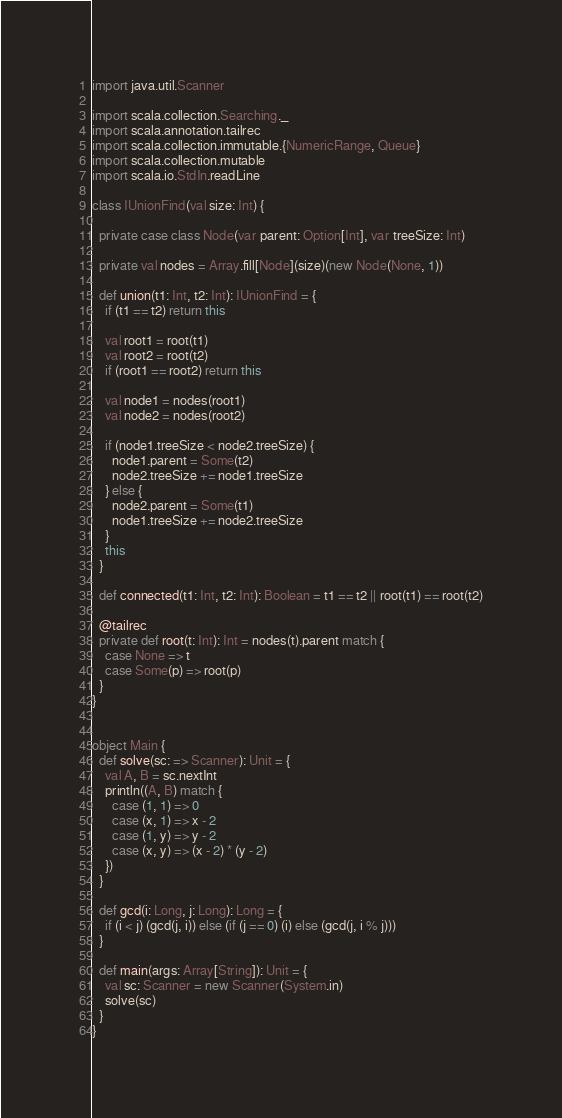Convert code to text. <code><loc_0><loc_0><loc_500><loc_500><_Scala_>import java.util.Scanner

import scala.collection.Searching._
import scala.annotation.tailrec
import scala.collection.immutable.{NumericRange, Queue}
import scala.collection.mutable
import scala.io.StdIn.readLine

class IUnionFind(val size: Int) {

  private case class Node(var parent: Option[Int], var treeSize: Int)

  private val nodes = Array.fill[Node](size)(new Node(None, 1))

  def union(t1: Int, t2: Int): IUnionFind = {
    if (t1 == t2) return this

    val root1 = root(t1)
    val root2 = root(t2)
    if (root1 == root2) return this

    val node1 = nodes(root1)
    val node2 = nodes(root2)

    if (node1.treeSize < node2.treeSize) {
      node1.parent = Some(t2)
      node2.treeSize += node1.treeSize
    } else {
      node2.parent = Some(t1)
      node1.treeSize += node2.treeSize
    }
    this
  }

  def connected(t1: Int, t2: Int): Boolean = t1 == t2 || root(t1) == root(t2)

  @tailrec
  private def root(t: Int): Int = nodes(t).parent match {
    case None => t
    case Some(p) => root(p)
  }
}


object Main {
  def solve(sc: => Scanner): Unit = {
    val A, B = sc.nextInt
    println((A, B) match {
      case (1, 1) => 0
      case (x, 1) => x - 2
      case (1, y) => y - 2
      case (x, y) => (x - 2) * (y - 2)
    })
  }

  def gcd(i: Long, j: Long): Long = {
    if (i < j) (gcd(j, i)) else (if (j == 0) (i) else (gcd(j, i % j)))
  }

  def main(args: Array[String]): Unit = {
    val sc: Scanner = new Scanner(System.in)
    solve(sc)
  }
}</code> 